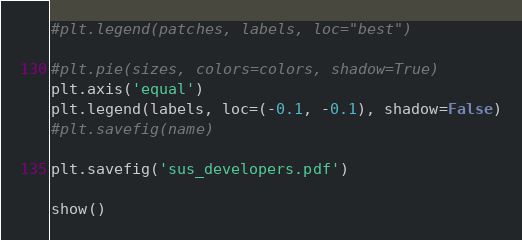Convert code to text. <code><loc_0><loc_0><loc_500><loc_500><_Python_>#plt.legend(patches, labels, loc="best")

#plt.pie(sizes, colors=colors, shadow=True)
plt.axis('equal')
plt.legend(labels, loc=(-0.1, -0.1), shadow=False)
#plt.savefig(name)

plt.savefig('sus_developers.pdf')

show()

</code> 